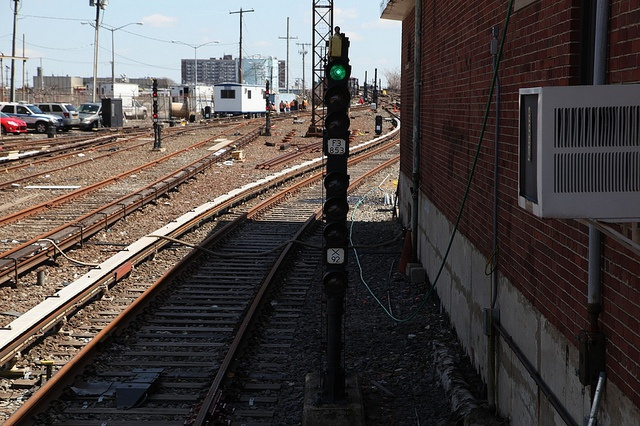Describe the objects in this image and their specific colors. I can see traffic light in lightblue, black, gray, darkgreen, and darkgray tones, train in lightblue, darkgray, white, black, and gray tones, truck in lightblue, darkgray, white, black, and gray tones, truck in lightblue, white, darkgray, gray, and black tones, and truck in lightblue, black, gray, white, and darkgray tones in this image. 